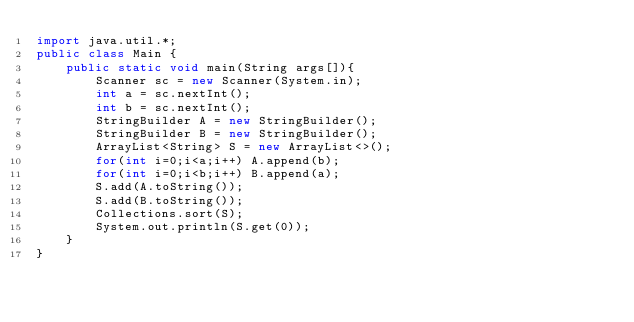Convert code to text. <code><loc_0><loc_0><loc_500><loc_500><_Java_>import java.util.*;
public class Main {
    public static void main(String args[]){
        Scanner sc = new Scanner(System.in);
        int a = sc.nextInt();
        int b = sc.nextInt();
        StringBuilder A = new StringBuilder();
        StringBuilder B = new StringBuilder();
        ArrayList<String> S = new ArrayList<>();
        for(int i=0;i<a;i++) A.append(b);
        for(int i=0;i<b;i++) B.append(a);
        S.add(A.toString());
        S.add(B.toString());
        Collections.sort(S);
        System.out.println(S.get(0));
    }
}</code> 